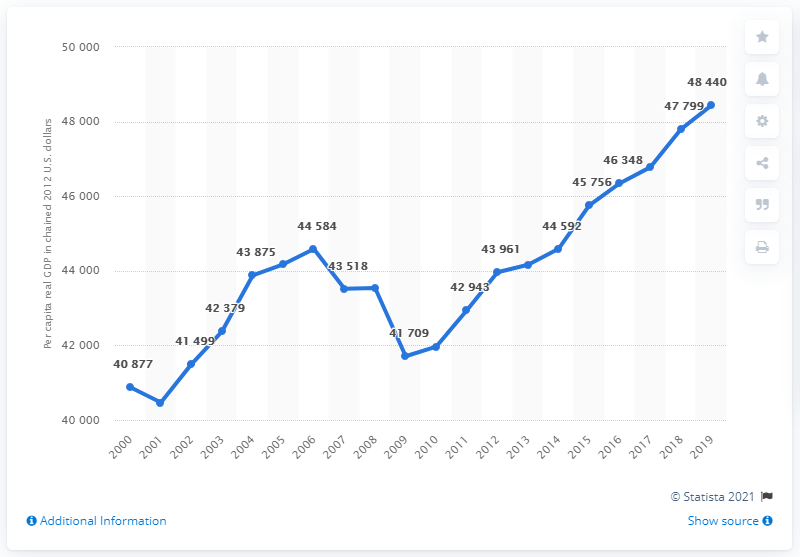Draw attention to some important aspects in this diagram. In the year 2019, the per capita real Gross Domestic Product of Tennessee reached its peak. The average for the last 4 years is 47085.75. 